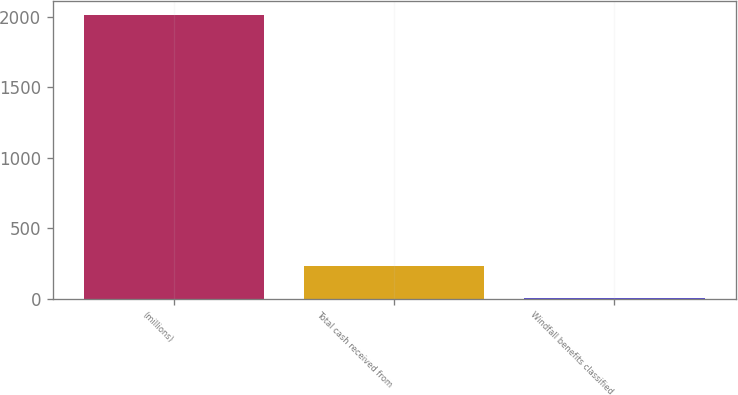<chart> <loc_0><loc_0><loc_500><loc_500><bar_chart><fcel>(millions)<fcel>Total cash received from<fcel>Windfall benefits classified<nl><fcel>2012<fcel>229<fcel>6<nl></chart> 